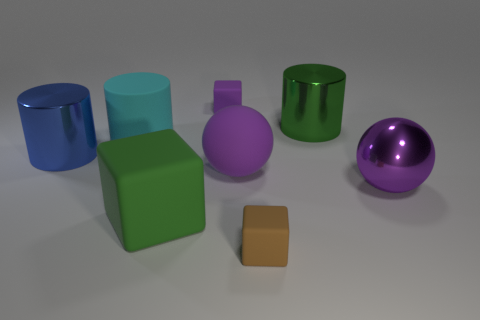There is a small matte object on the right side of the tiny thing that is behind the tiny matte object in front of the tiny purple matte thing; what is its shape?
Ensure brevity in your answer.  Cube. How many other objects are there of the same color as the big matte cube?
Give a very brief answer. 1. Is the number of rubber objects in front of the big matte cylinder greater than the number of large green rubber objects left of the purple rubber ball?
Offer a very short reply. Yes. There is a small brown matte thing; are there any blue cylinders on the right side of it?
Offer a very short reply. No. There is a block that is both in front of the metal ball and to the right of the large green matte object; what material is it made of?
Offer a terse response. Rubber. What is the color of the rubber object that is the same shape as the purple shiny object?
Provide a succinct answer. Purple. Is there a big matte block right of the small matte thing that is in front of the large blue metal cylinder?
Your answer should be compact. No. The green rubber thing is what size?
Offer a very short reply. Large. There is a object that is behind the cyan cylinder and left of the large green metallic thing; what shape is it?
Provide a succinct answer. Cube. How many cyan things are either large matte things or big metal balls?
Give a very brief answer. 1. 